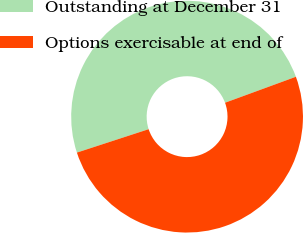Convert chart to OTSL. <chart><loc_0><loc_0><loc_500><loc_500><pie_chart><fcel>Outstanding at December 31<fcel>Options exercisable at end of<nl><fcel>49.43%<fcel>50.57%<nl></chart> 